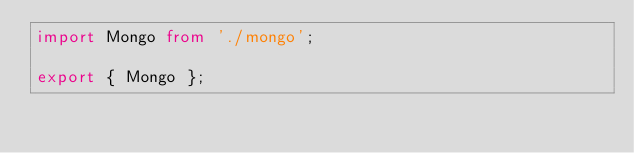Convert code to text. <code><loc_0><loc_0><loc_500><loc_500><_TypeScript_>import Mongo from './mongo';

export { Mongo };
</code> 